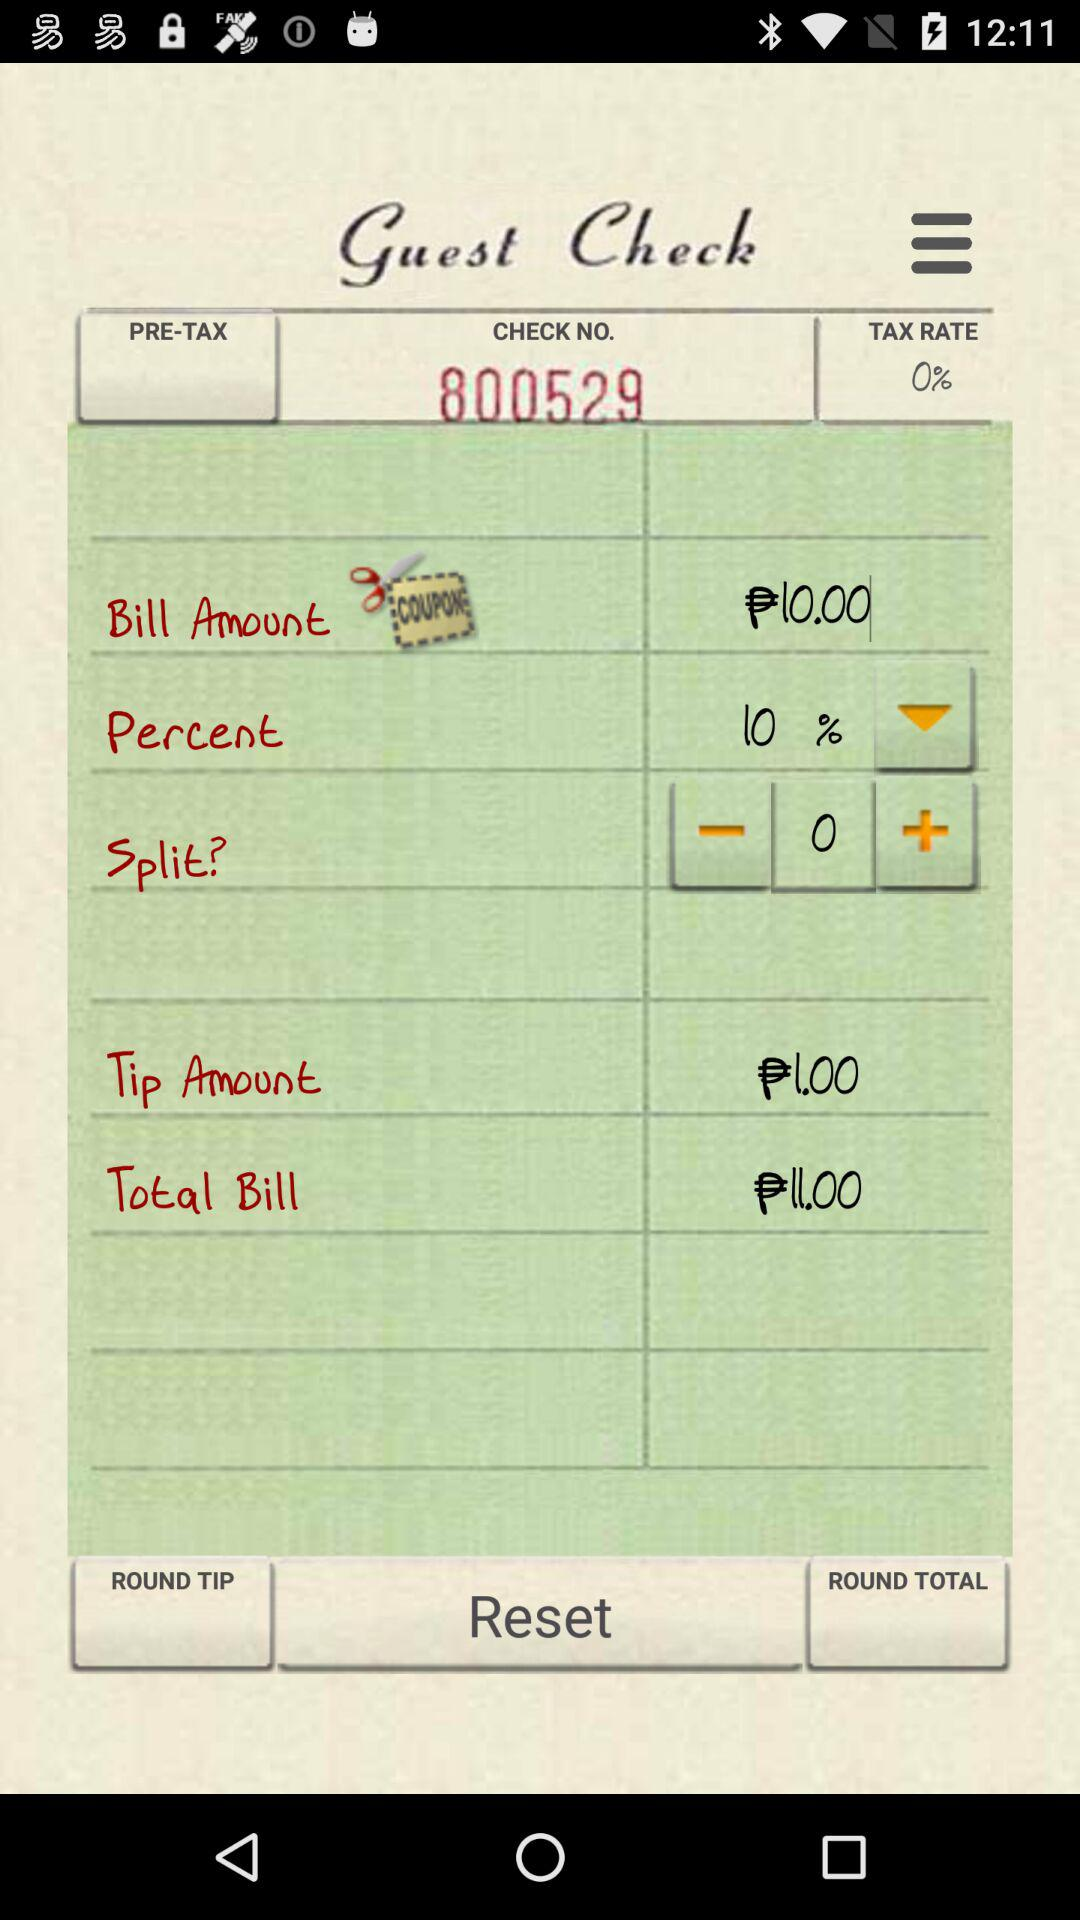How much is the bill amount? The bill amount is ₱10.00. 